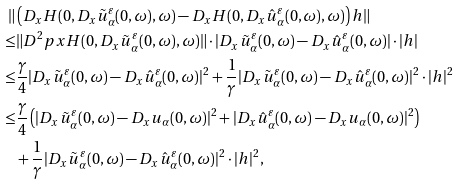Convert formula to latex. <formula><loc_0><loc_0><loc_500><loc_500>\| & \left ( D _ { x } H ( 0 , D _ { x } \tilde { u } _ { \alpha } ^ { \varepsilon } ( 0 , \omega ) , \omega ) - D _ { x } H ( 0 , D _ { x } \hat { u } _ { \alpha } ^ { \varepsilon } ( 0 , \omega ) , \omega ) \right ) h \| \\ \leq & \| D ^ { 2 } { p x } H ( 0 , D _ { x } \tilde { u } _ { \alpha } ^ { \varepsilon } ( 0 , \omega ) , \omega ) \| \cdot | D _ { x } \tilde { u } _ { \alpha } ^ { \varepsilon } ( 0 , \omega ) - D _ { x } \hat { u } _ { \alpha } ^ { \varepsilon } ( 0 , \omega ) | \cdot | h | \\ \leq & \frac { \gamma } { 4 } | D _ { x } \tilde { u } _ { \alpha } ^ { \varepsilon } ( 0 , \omega ) - D _ { x } \hat { u } _ { \alpha } ^ { \varepsilon } ( 0 , \omega ) | ^ { 2 } + \frac { 1 } { \gamma } | D _ { x } \tilde { u } _ { \alpha } ^ { \varepsilon } ( 0 , \omega ) - D _ { x } \hat { u } _ { \alpha } ^ { \varepsilon } ( 0 , \omega ) | ^ { 2 } \cdot | h | ^ { 2 } \\ \leq & \frac { \gamma } { 4 } \left ( | D _ { x } \tilde { u } _ { \alpha } ^ { \varepsilon } ( 0 , \omega ) - D _ { x } u _ { \alpha } ( 0 , \omega ) | ^ { 2 } + | D _ { x } \hat { u } _ { \alpha } ^ { \varepsilon } ( 0 , \omega ) - D _ { x } u _ { \alpha } ( 0 , \omega ) | ^ { 2 } \right ) \\ & + \frac { 1 } { \gamma } | D _ { x } \tilde { u } _ { \alpha } ^ { \varepsilon } ( 0 , \omega ) - D _ { x } \hat { u } _ { \alpha } ^ { \varepsilon } ( 0 , \omega ) | ^ { 2 } \cdot | h | ^ { 2 } ,</formula> 